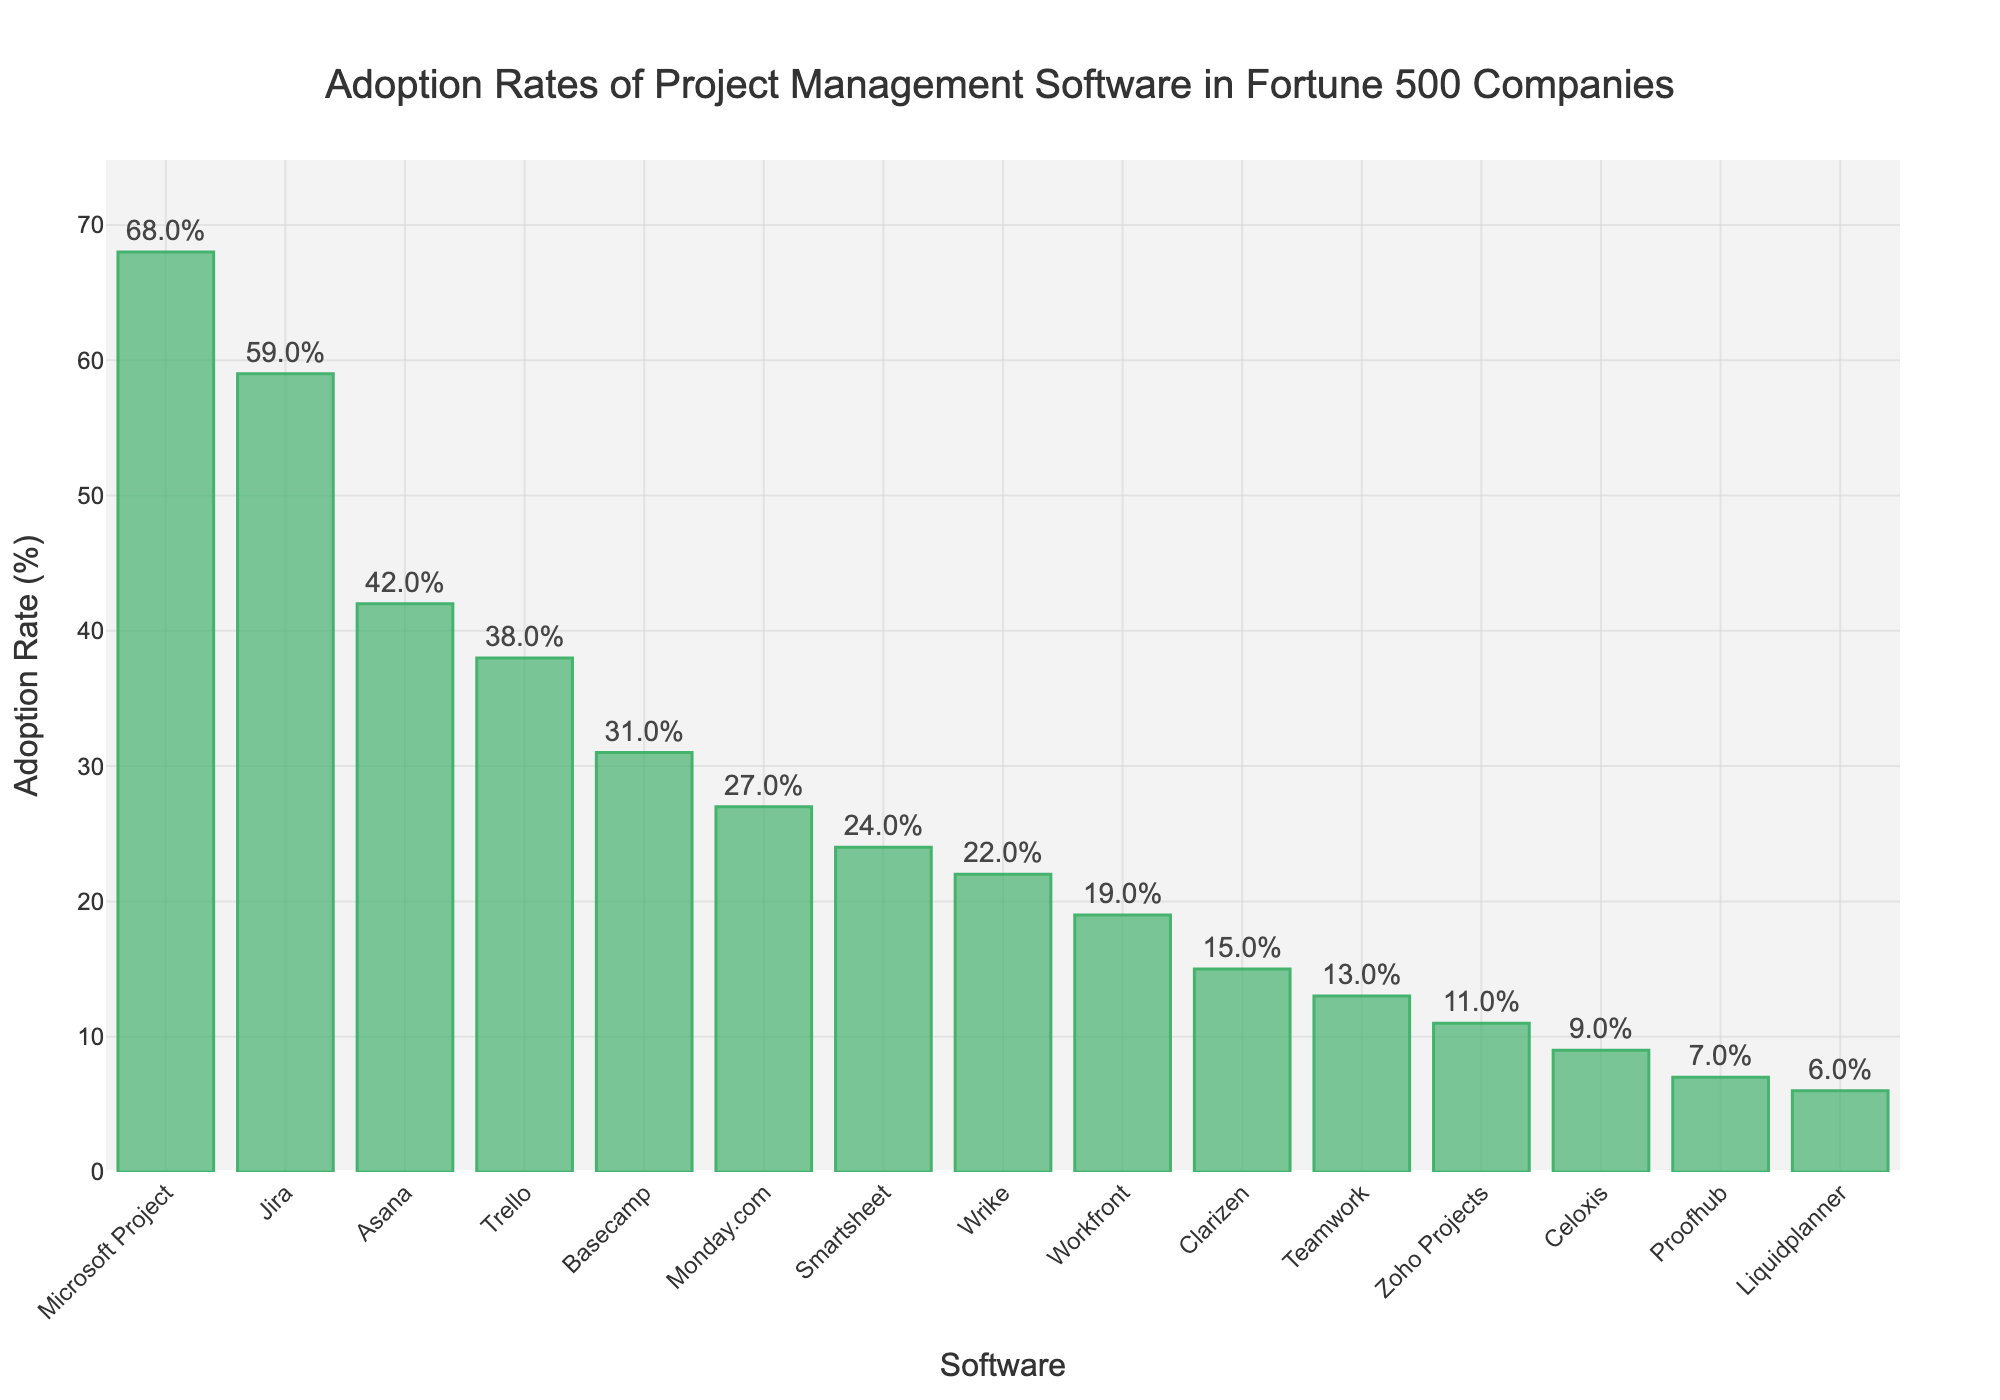Which software tool has the highest adoption rate? From the bar chart, the height of the bar for "Microsoft Project" is the highest, indicating it has the highest adoption rate.
Answer: Microsoft Project Which two software tools have nearly similar adoption rates? By examining the height of the bars, "Asana" has an adoption rate of 42% and "Trello" has an adoption rate of 38%, which are close to each other.
Answer: Asana and Trello What is the total adoption rate of the top three software tools combined? The top three software tools by adoption rate are "Microsoft Project" (68%), "Jira" (59%), and "Asana" (42%). Summing these values, 68 + 59 + 42 = 169.
Answer: 169 How many software tools have an adoption rate lower than 20%? By counting the bars that fall below the 20% mark, we find "Workfront," "Clarizen," "Teamwork," "Zoho Projects," "Celoxis," "Proofhub," and "Liquidplanner," which total seven tools.
Answer: 7 Which software tool has an adoption rate closest to 50%? By inspecting the bar heights, "Jira" with an adoption rate of 59% is the closest to 50%.
Answer: Jira Which software tools have adoption rates between 20% and 40%? The software tools that fall in this range are "Trello" (38%), "Basecamp" (31%), and "Monday.com" (27%).
Answer: Trello, Basecamp, and Monday.com By how many percentage points does Microsoft Project exceed the second highest tool in adoption rate? Microsoft Project has an adoption rate of 68%, and the second highest, Jira, has 59%. The difference is 68 - 59 = 9 percentage points.
Answer: 9 What is the average adoption rate of the tools with more than 30% adoption? The tools with more than 30% adoption are "Microsoft Project" (68%), "Jira" (59%), "Asana" (42%), "Trello" (38%), and "Basecamp" (31%). Summing these values, 68 + 59 + 42 + 38 + 31 = 238; the average is 238 / 5 = 47.6%.
Answer: 47.6% Which bar is the shortest? The shortest bar corresponds to "Liquidplanner," indicating it has the lowest adoption rate.
Answer: Liquidplanner What is the median adoption rate among all the tools? Sorting the adoption rates: 6, 7, 9, 11, 13, 15, 19, 22, 24, 27, 31, 38, 42, 59, 68. The median value is the middle one, which is 22 (Wrike).
Answer: 22 